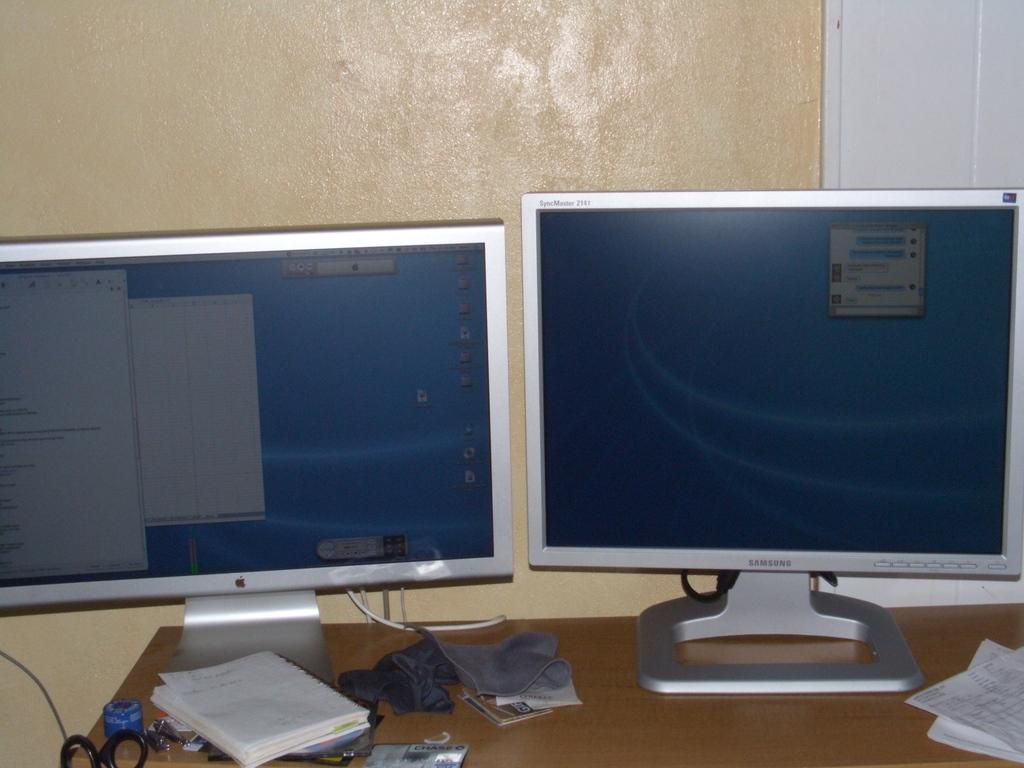<image>
Create a compact narrative representing the image presented. An apple monitor is displaying a blue background 